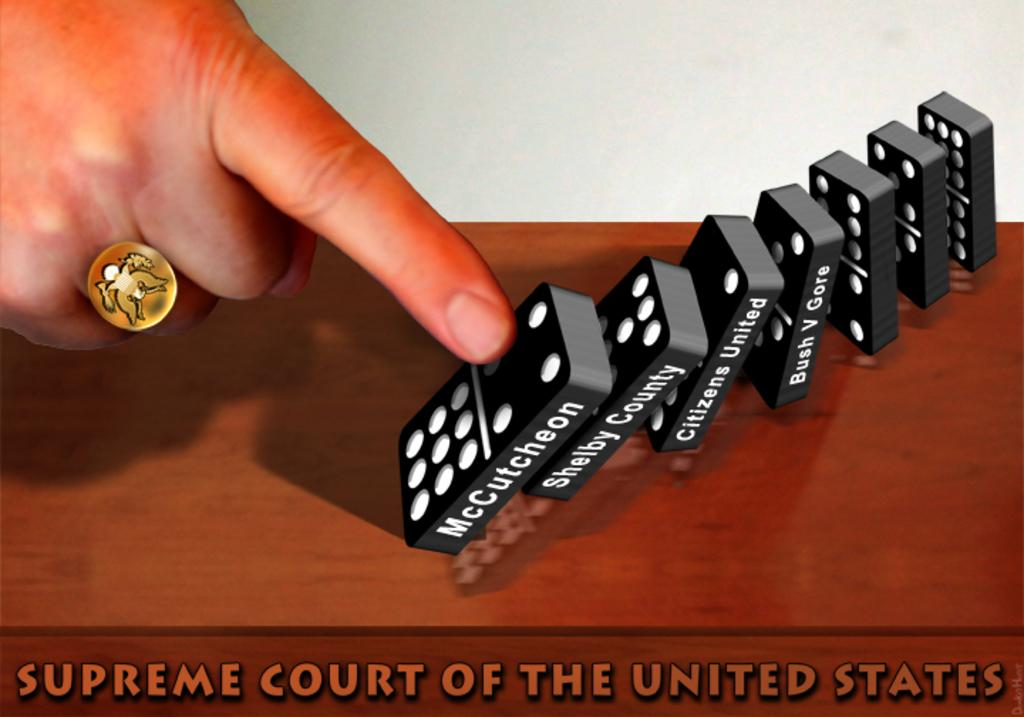<image>
Offer a succinct explanation of the picture presented. A political statement using dominoes to show the role of the Supreme Court of The United States. 